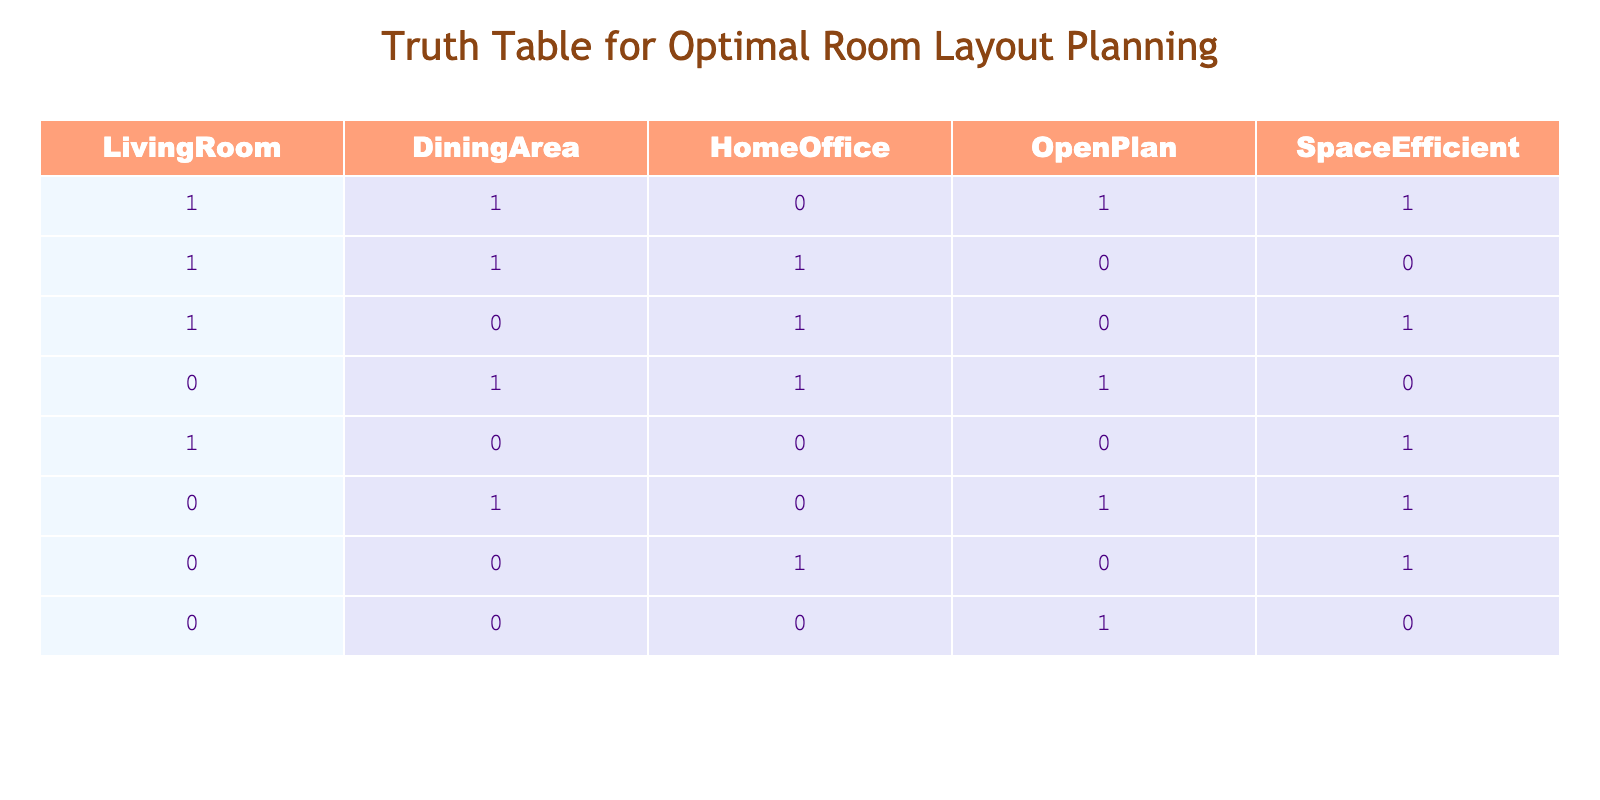What is the total number of configurations where the Living Room and Dining Area are both included? By examining the rows in the table, we find configurations where both the Living Room and Dining Area are '1'. These rows are the first two: (1, 1, 0, 1, 1) and (1, 1, 1, 0, 0). There are 2 such configurations.
Answer: 2 In how many configurations is the Home Office not included while having an Open Plan? Looking at the table, we filter for rows where the Home Office is '0' and the Open Plan is '1'. The relevant rows are (1, 1, 0, 1, 1) and (0, 1, 0, 1, 1). Therefore, there are 2 configurations that meet this criterion.
Answer: 2 Are there any configurations where the Living Room is not included? We scan the table for rows where the Living Room is '0'. These rows are (0, 1, 1, 1, 0), (1, 0, 0, 0, 1), (0, 1, 0, 1, 1), and (0, 0, 1, 0, 1). This means there are 4 configurations without the Living Room.
Answer: Yes What is the cumulative total of Space Efficient configurations? We count the '1's in the Space Efficient column. From the table, the relevant rows are (1, 1, 0, 1, 1), (0, 1, 0, 1, 1), (0, 0, 1, 0, 1), which gives us 3 configurations with a value of '1' in Space Efficient.
Answer: 3 Is it true that having an Open Plan always indicates a Space Efficient room layout? We need to check rows where Open Plan is '1' and see if Space Efficient is also '1'. The relevant rows are (1, 1, 0, 1, 1), (0, 1, 0, 1, 1), and (0, 0, 0, 1, 0). The last row shows a Space Efficient value of '0', so it is false to say that Open Plan always indicates Space Efficient.
Answer: No How many more configurations are there with a Dining Area than without it? We count configurations with Dining Area as '1' from row 1, 2, and 4 (total = 4), and those without it from rows 3, 5, 6, 7, 8 (total = 4). Therefore, there is an equal number of configurations with and without a Dining Area, making it zero more.
Answer: 0 Which configuration has the maximum number of rooms included? The row (1, 1, 1, 0, 0) includes three rooms out of the four possible (Living Room, Dining Area, Home Office) at the maximum. Thus, this configuration stands out with three rooms included.
Answer: (1, 1, 1, 0, 0) What is the average number of rooms included across all configurations? We count the total rooms across each row and add them: (3 + 3 + 2 + 3 + 1 + 2 + 1 + 0) = 15. There are a total of 8 configurations, so the average is 15 / 8 = 1.875.
Answer: 1.875 